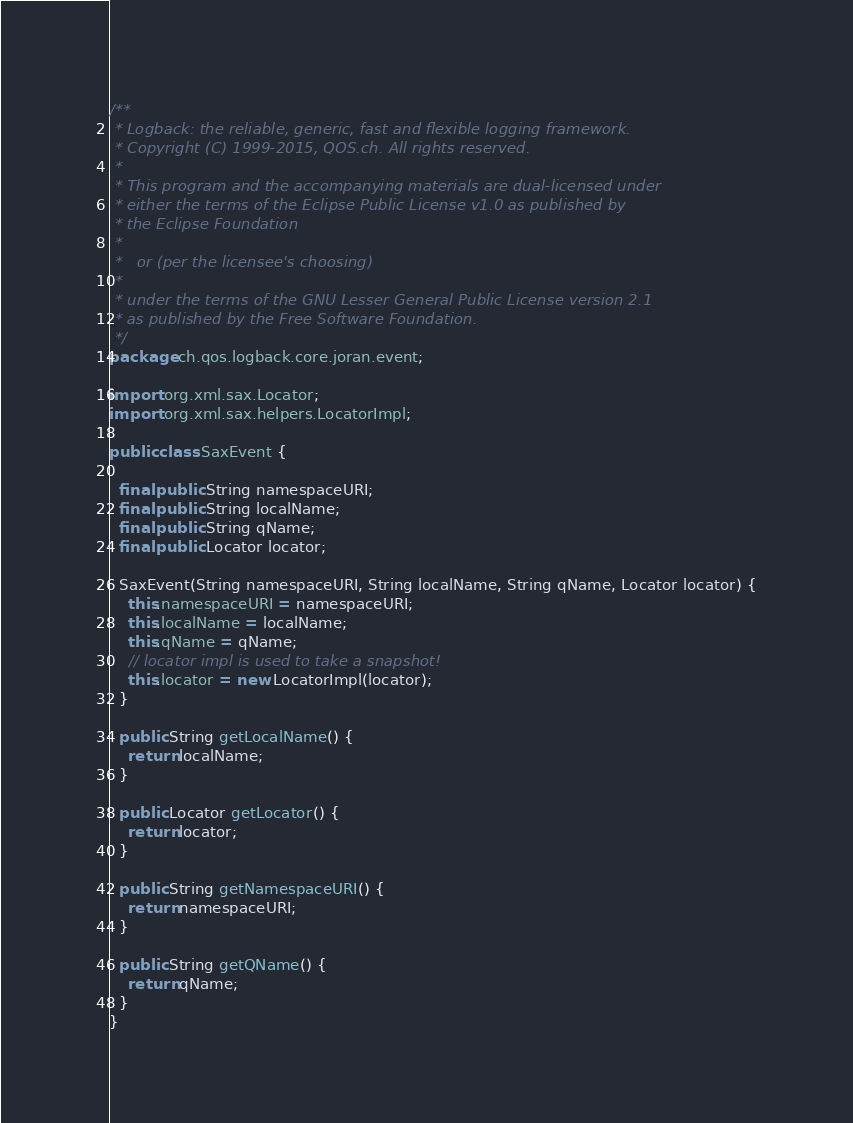<code> <loc_0><loc_0><loc_500><loc_500><_Java_>/**
 * Logback: the reliable, generic, fast and flexible logging framework.
 * Copyright (C) 1999-2015, QOS.ch. All rights reserved.
 *
 * This program and the accompanying materials are dual-licensed under
 * either the terms of the Eclipse Public License v1.0 as published by
 * the Eclipse Foundation
 *
 *   or (per the licensee's choosing)
 *
 * under the terms of the GNU Lesser General Public License version 2.1
 * as published by the Free Software Foundation.
 */
package ch.qos.logback.core.joran.event;

import org.xml.sax.Locator;
import org.xml.sax.helpers.LocatorImpl;

public class SaxEvent {

  final public String namespaceURI;
  final public String localName;
  final public String qName;
  final public Locator locator;

  SaxEvent(String namespaceURI, String localName, String qName, Locator locator) {
    this.namespaceURI = namespaceURI;
    this.localName = localName;
    this.qName = qName;
    // locator impl is used to take a snapshot!
    this.locator = new LocatorImpl(locator);
  }

  public String getLocalName() {
    return localName;
  }

  public Locator getLocator() {
    return locator;
  }

  public String getNamespaceURI() {
    return namespaceURI;
  }

  public String getQName() {
    return qName;
  }
}
</code> 